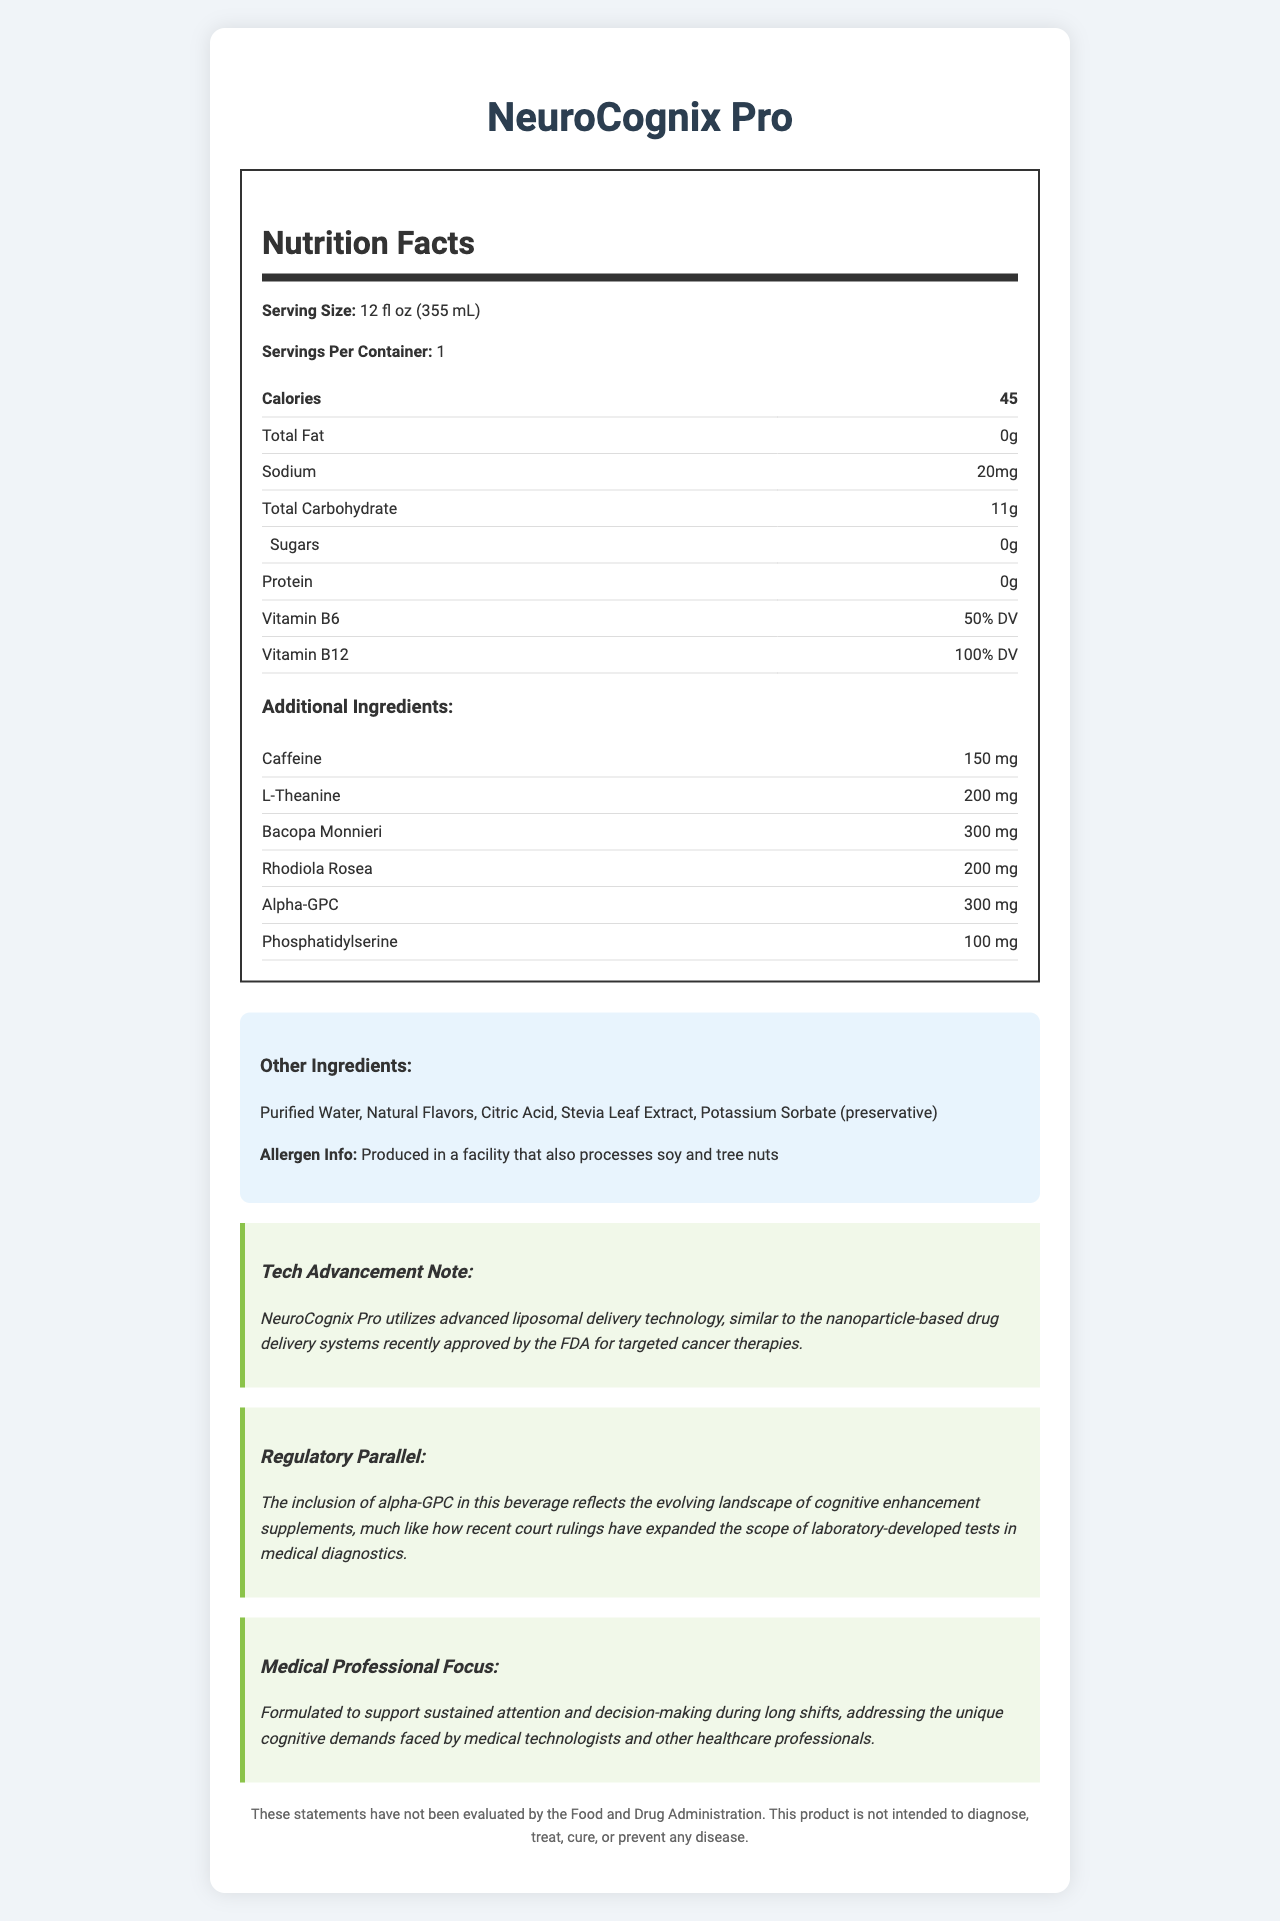what is the serving size? The serving size is provided at the top of the Nutrition Facts section: "Serving Size: 12 fl oz (355 mL)".
Answer: 12 fl oz (355 mL) how much caffeine is in the beverage? The amount of caffeine is listed under the "Additional Ingredients" section: "Caffeine: 150 mg".
Answer: 150 mg how many calories are in a serving? The calorie content is shown in the Nutrition Facts table: "Calories: 45".
Answer: 45 list two main ingredients in the beverage besides water The "Other Ingredients" section lists the main ingredients: "Purified Water, Natural Flavors, Citric Acid, Stevia Leaf Extract, Potassium Sorbate (preservative)".
Answer: Natural Flavors, Citric Acid does the product contain any protein? The Nutrition Facts table lists the protein content as "0g": "Protein: 0g".
Answer: No how is the product designed to benefit medical professionals? The "Medical Professional Focus" section describes the product's benefits: "Formulated to support sustained attention and decision-making during long shifts".
Answer: Sustained attention and decision-making during long shifts which vitamin is present at 100% Daily Value? A. Vitamin A B. Vitamin B6 C. Vitamin B12 D. Vitamin C The Nutrition Facts table lists Vitamin B12 at "100% DV".
Answer: C. Vitamin B12 which of the following is NOT an additional ingredient of the beverage? I. Bacopa Monnieri II. L-Theanine III. Vitamin C IV. Rhodiola Rosea Vitamin C is not listed among the additional ingredients, while Bacopa Monnieri, L-Theanine, and Rhodiola Rosea are included.
Answer: III. Vitamin C is the product produced in a nut-free facility? The allergen information states: "Produced in a facility that also processes soy and tree nuts".
Answer: No summarize the main purpose of this document The document details the serving size, calorie content, key vitamins and ingredients, allergen information, advances in technology used, and its focus on supporting medical professionals.
Answer: To provide detailed nutritional, ingredient, technical, and regulatory information about NeuroCognix Pro, a beverage designed to boost cognitive performance in medical professionals. what percentage of your Daily Value of Vitamin B6 does the beverage provide? The Nutrition Facts table lists the Vitamin B6 content as "50% DV".
Answer: 50% what is the total carbohydrate content of the beverage? The Nutrition Facts table lists the total carbohydrate content as "Total Carbohydrate: 11g".
Answer: 11g how much sodium is in one serving? The Nutrition Facts table lists the sodium content as "Sodium: 20mg".
Answer: 20 mg what advanced technology does NeuroCognix Pro utilize? The "Tech Advancement Note" mentions that NeuroCognix Pro utilizes "advanced liposomal delivery technology".
Answer: Liposomal delivery technology compare the legal disclaimer with typical disclaimers found on other supplements The legal disclaimer for NeuroCognix Pro is typical for supplements, noting it is not FDA evaluated and not intended as a medical treatment.
Answer: Similar; states the product is not evaluated by FDA and is not intended to diagnose, treat, cure, or prevent any disease. who is the target audience for NeuroCognix Pro? The "Medical Professional Focus" section states it is "formulated to support... ideas faced by medical technologists and other healthcare professionals."
Answer: Medical technologists and healthcare professionals how does the regulatory landscape for supplements mentioned in the document compare to lab tests in medical diagnostics? The "Regulatory Parallel" note describes the evolving landscape of cognitive enhancement supplements, similar to the expanding scope of laboratory-developed tests in medical diagnostics.
Answer: Both are evolving and expanding in scope does the product contain any sugars? The Nutrition Facts table lists the sugars content as "Sugars: 0g".
Answer: No what is the main delivery technology highlighted in the tech advancement note? The "Tech Advancement Note" section highlights "liposomal delivery technology" as the main delivery method.
Answer: Liposomal delivery technology 